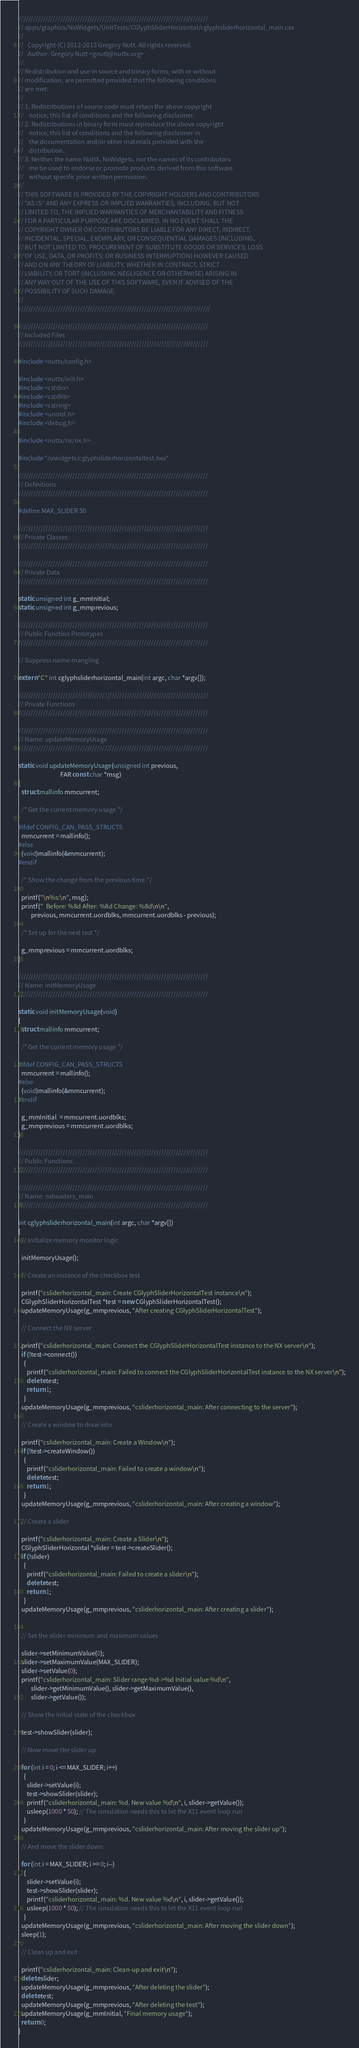<code> <loc_0><loc_0><loc_500><loc_500><_C++_>/////////////////////////////////////////////////////////////////////////////
// apps/graphics/NxWidgets/UnitTests/CGlyphSliderHorizontal/cglyphsliderhorizontal_main.cxx
//
//   Copyright (C) 2012-2013 Gregory Nutt. All rights reserved.
//   Author: Gregory Nutt <gnutt@nuttx.org>
//
// Redistribution and use in source and binary forms, with or without
// modification, are permitted provided that the following conditions
// are met:
//
// 1. Redistributions of source code must retain the above copyright
//    notice, this list of conditions and the following disclaimer.
// 2. Redistributions in binary form must reproduce the above copyright
//    notice, this list of conditions and the following disclaimer in
//    the documentation and/or other materials provided with the
//    distribution.
// 3. Neither the name NuttX, NxWidgets, nor the names of its contributors
//    me be used to endorse or promote products derived from this software
//    without specific prior written permission.
//
// THIS SOFTWARE IS PROVIDED BY THE COPYRIGHT HOLDERS AND CONTRIBUTORS
// "AS IS" AND ANY EXPRESS OR IMPLIED WARRANTIES, INCLUDING, BUT NOT
// LIMITED TO, THE IMPLIED WARRANTIES OF MERCHANTABILITY AND FITNESS
// FOR A PARTICULAR PURPOSE ARE DISCLAIMED. IN NO EVENT SHALL THE
// COPYRIGHT OWNER OR CONTRIBUTORS BE LIABLE FOR ANY DIRECT, INDIRECT,
// INCIDENTAL, SPECIAL, EXEMPLARY, OR CONSEQUENTIAL DAMAGES (INCLUDING,
// BUT NOT LIMITED TO, PROCUREMENT OF SUBSTITUTE GOODS OR SERVICES; LOSS
// OF USE, DATA, OR PROFITS; OR BUSINESS INTERRUPTION) HOWEVER CAUSED
// AND ON ANY THEORY OF LIABILITY, WHETHER IN CONTRACT, STRICT
// LIABILITY, OR TORT (INCLUDING NEGLIGENCE OR OTHERWISE) ARISING IN
// ANY WAY OUT OF THE USE OF THIS SOFTWARE, EVEN IF ADVISED OF THE
// POSSIBILITY OF SUCH DAMAGE.
//
//////////////////////////////////////////////////////////////////////////////

/////////////////////////////////////////////////////////////////////////////
// Included Files
/////////////////////////////////////////////////////////////////////////////

#include <nuttx/config.h>

#include <nuttx/init.h>
#include <cstdio>
#include <cstdlib>
#include <cstring>
#include <unistd.h>
#include <debug.h>

#include <nuttx/nx/nx.h>

#include "nxwidgets/cglyphsliderhorizontaltest.hxx"

/////////////////////////////////////////////////////////////////////////////
// Definitions
/////////////////////////////////////////////////////////////////////////////

#define MAX_SLIDER 50

/////////////////////////////////////////////////////////////////////////////
// Private Classes
/////////////////////////////////////////////////////////////////////////////

/////////////////////////////////////////////////////////////////////////////
// Private Data
/////////////////////////////////////////////////////////////////////////////

static unsigned int g_mmInitial;
static unsigned int g_mmprevious;

/////////////////////////////////////////////////////////////////////////////
// Public Function Prototypes
/////////////////////////////////////////////////////////////////////////////

// Suppress name-mangling

extern "C" int cglyphsliderhorizontal_main(int argc, char *argv[]);

/////////////////////////////////////////////////////////////////////////////
// Private Functions
/////////////////////////////////////////////////////////////////////////////

/////////////////////////////////////////////////////////////////////////////
// Name: updateMemoryUsage
/////////////////////////////////////////////////////////////////////////////

static void updateMemoryUsage(unsigned int previous,
                              FAR const char *msg)
{
  struct mallinfo mmcurrent;

  /* Get the current memory usage */

#ifdef CONFIG_CAN_PASS_STRUCTS
  mmcurrent = mallinfo();
#else
  (void)mallinfo(&mmcurrent);
#endif

  /* Show the change from the previous time */

  printf("\n%s:\n", msg);
  printf("  Before: %8d After: %8d Change: %8d\n\n",
         previous, mmcurrent.uordblks, mmcurrent.uordblks - previous);

  /* Set up for the next test */

  g_mmprevious = mmcurrent.uordblks;
}

/////////////////////////////////////////////////////////////////////////////
// Name: initMemoryUsage
/////////////////////////////////////////////////////////////////////////////

static void initMemoryUsage(void)
{
  struct mallinfo mmcurrent;

  /* Get the current memory usage */

#ifdef CONFIG_CAN_PASS_STRUCTS
  mmcurrent = mallinfo();
#else
  (void)mallinfo(&mmcurrent);
#endif

  g_mmInitial  = mmcurrent.uordblks;
  g_mmprevious = mmcurrent.uordblks;
}

/////////////////////////////////////////////////////////////////////////////
// Public Functions
/////////////////////////////////////////////////////////////////////////////

/////////////////////////////////////////////////////////////////////////////
// Name: nxheaders_main
/////////////////////////////////////////////////////////////////////////////

int cglyphsliderhorizontal_main(int argc, char *argv[])
{
  // Initialize memory monitor logic

  initMemoryUsage();

  // Create an instance of the checkbox test

  printf("csliderhorizontal_main: Create CGlyphSliderHorizontalTest instance\n");
  CGlyphSliderHorizontalTest *test = new CGlyphSliderHorizontalTest();
  updateMemoryUsage(g_mmprevious, "After creating CGlyphSliderHorizontalTest");

  // Connect the NX server

  printf("csliderhorizontal_main: Connect the CGlyphSliderHorizontalTest instance to the NX server\n");
  if (!test->connect())
    {
      printf("csliderhorizontal_main: Failed to connect the CGlyphSliderHorizontalTest instance to the NX server\n");
      delete test;
      return 1;
    }
  updateMemoryUsage(g_mmprevious, "csliderhorizontal_main: After connecting to the server");

  // Create a window to draw into

  printf("csliderhorizontal_main: Create a Window\n");
  if (!test->createWindow())
    {
      printf("csliderhorizontal_main: Failed to create a window\n");
      delete test;
      return 1;
    }
  updateMemoryUsage(g_mmprevious, "csliderhorizontal_main: After creating a window");

  // Create a slider

  printf("csliderhorizontal_main: Create a Slider\n");
  CGlyphSliderHorizontal *slider = test->createSlider();
  if (!slider)
    {
      printf("csliderhorizontal_main: Failed to create a slider\n");
      delete test;
      return 1;
    }
  updateMemoryUsage(g_mmprevious, "csliderhorizontal_main: After creating a slider");


  // Set the slider minimum and maximum values

  slider->setMinimumValue(0);
  slider->setMaximumValue(MAX_SLIDER);
  slider->setValue(0);
  printf("csliderhorizontal_main: Slider range %d->%d Initial value %d\n",
         slider->getMinimumValue(), slider->getMaximumValue(),
         slider->getValue());

  // Show the initial state of the checkbox

  test->showSlider(slider);

  // Now move the slider up

  for (int i = 0; i <= MAX_SLIDER; i++)
    {
      slider->setValue(i);
      test->showSlider(slider);
      printf("csliderhorizontal_main: %d. New value %d\n", i, slider->getValue());
      usleep(1000 * 50); // The simulation needs this to let the X11 event loop run
    }
  updateMemoryUsage(g_mmprevious, "csliderhorizontal_main: After moving the slider up");

  // And move the slider down

  for (int i = MAX_SLIDER; i >= 0; i--)
    {
      slider->setValue(i);
      test->showSlider(slider);
      printf("csliderhorizontal_main: %d. New value %d\n", i, slider->getValue());
      usleep(1000 * 50); // The simulation needs this to let the X11 event loop run
    }
  updateMemoryUsage(g_mmprevious, "csliderhorizontal_main: After moving the slider down");
  sleep(1);

  // Clean up and exit

  printf("csliderhorizontal_main: Clean-up and exit\n");
  delete slider;
  updateMemoryUsage(g_mmprevious, "After deleting the slider");
  delete test;
  updateMemoryUsage(g_mmprevious, "After deleting the test");
  updateMemoryUsage(g_mmInitial, "Final memory usage");
  return 0;
}
</code> 